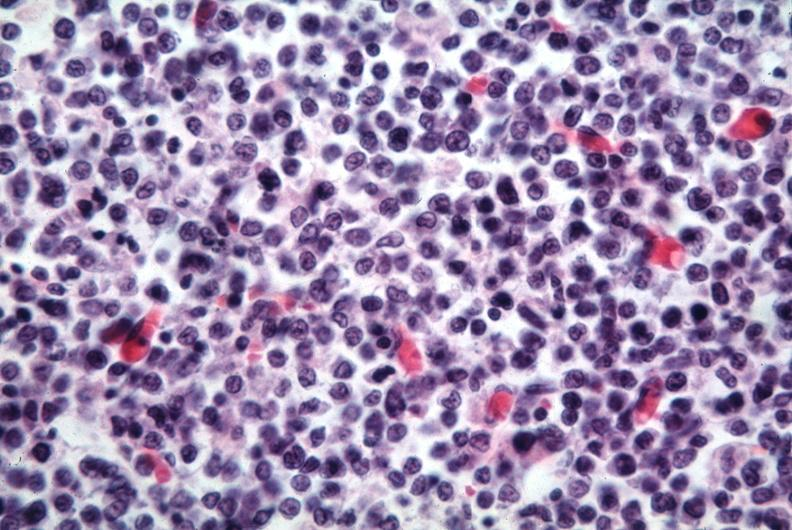what is present?
Answer the question using a single word or phrase. Lymphoblastic lymphoma 